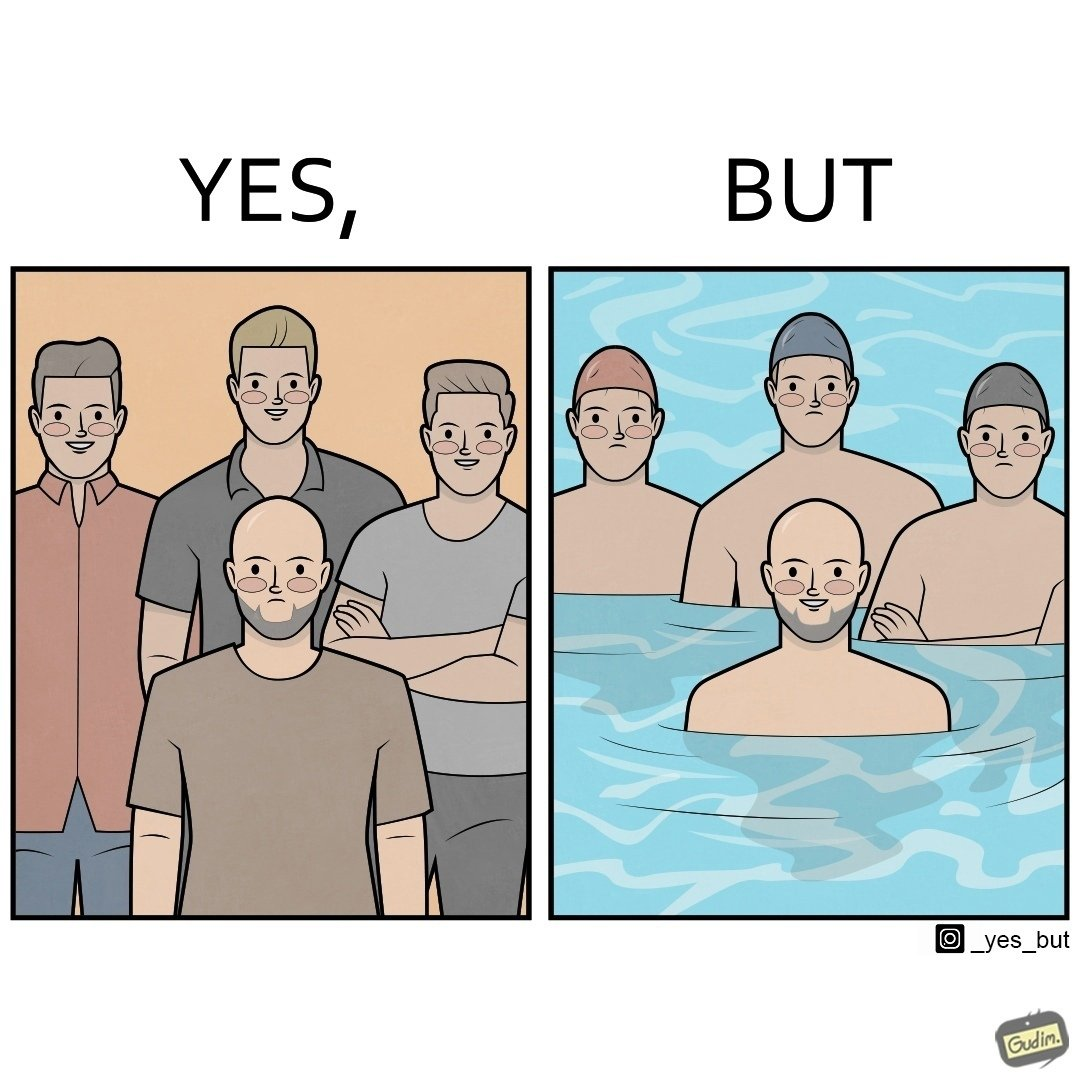Is this a satirical image? Yes, this image is satirical. 